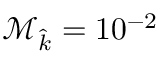Convert formula to latex. <formula><loc_0><loc_0><loc_500><loc_500>\mathcal { M } _ { \widehat { k } } = 1 0 ^ { - 2 }</formula> 